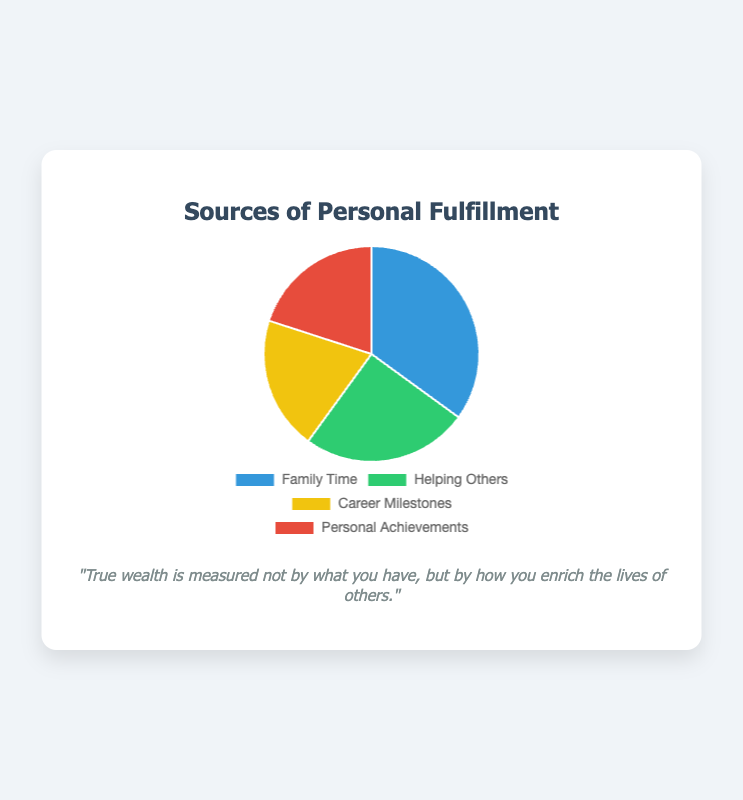What is the largest source of personal fulfillment? To determine the largest source of personal fulfillment, look at the percentages represented by each category on the pie chart. "Family Time" has the highest percentage at 35%.
Answer: Family Time How much more does "Family Time" contribute to personal fulfillment compared to "Helping Others"? To find the difference between "Family Time" and "Helping Others", subtract the percentage of "Helping Others" from the percentage of "Family Time". 35% - 25% = 10%.
Answer: 10% Which sources of personal fulfillment have equal contributions? Look for categories with the same percentage. "Career Milestones" and "Personal Achievements" both contribute 20% each.
Answer: Career Milestones and Personal Achievements What is the total contribution of "Career Milestones" and "Personal Achievements"? Add the percentages of "Career Milestones" and "Personal Achievements" together. 20% + 20% = 40%.
Answer: 40% What percentage of personal fulfillment comes from non-family sources? Add the percentages of "Helping Others", "Career Milestones", and "Personal Achievements". 25% + 20% + 20% = 65%.
Answer: 65% Which category is represented by the color blue? Observe the color associated with each category. "Family Time" is represented by the color blue.
Answer: Family Time Is the total contribution of "Helping Others" and "Family Time" greater than 50%? Add the percentages of "Helping Others" and "Family Time". Check if the sum is greater than 50%. 25% + 35% = 60%, which is greater than 50%.
Answer: Yes What is the combined difference between "Family Time" and the two categories "Career Milestones" and "Personal Achievements"? Calculate the difference between "Family Time" and each category individually, then sum them up. (35% - 20%) + (35% - 20%) = 15% + 15% = 30%.
Answer: 30% Which category is depicted by the green color? Look at the color code and identify the category represented by green. "Helping Others" is depicted by the green color.
Answer: Helping Others 